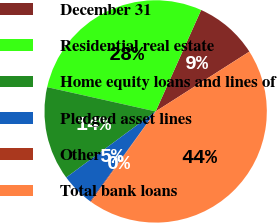Convert chart to OTSL. <chart><loc_0><loc_0><loc_500><loc_500><pie_chart><fcel>December 31<fcel>Residential real estate<fcel>Home equity loans and lines of<fcel>Pledged asset lines<fcel>Other<fcel>Total bank loans<nl><fcel>9.25%<fcel>28.2%<fcel>13.63%<fcel>4.88%<fcel>0.12%<fcel>43.91%<nl></chart> 